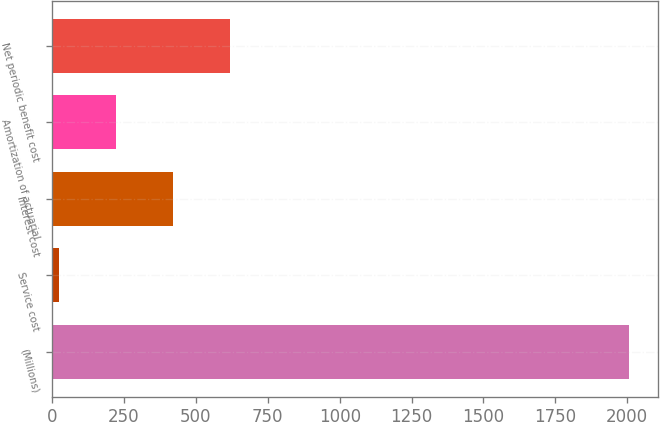<chart> <loc_0><loc_0><loc_500><loc_500><bar_chart><fcel>(Millions)<fcel>Service cost<fcel>Interest cost<fcel>Amortization of actuarial<fcel>Net periodic benefit cost<nl><fcel>2005<fcel>24<fcel>420.2<fcel>222.1<fcel>618.3<nl></chart> 